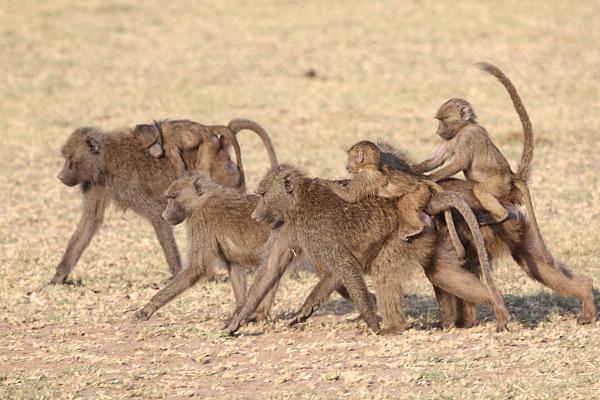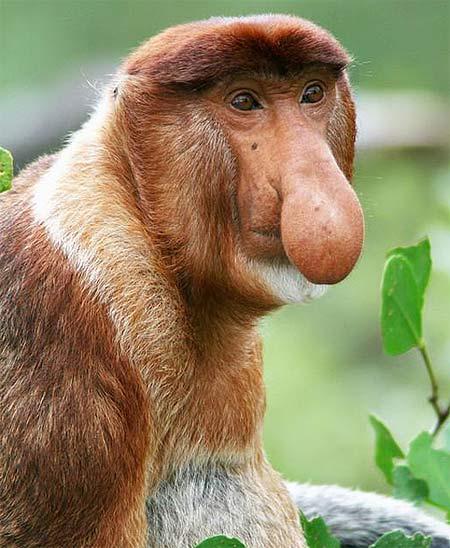The first image is the image on the left, the second image is the image on the right. For the images shown, is this caption "There is more than one monkey in the left image." true? Answer yes or no. Yes. The first image is the image on the left, the second image is the image on the right. Assess this claim about the two images: "At least one of the animals is showing its teeth.". Correct or not? Answer yes or no. No. 